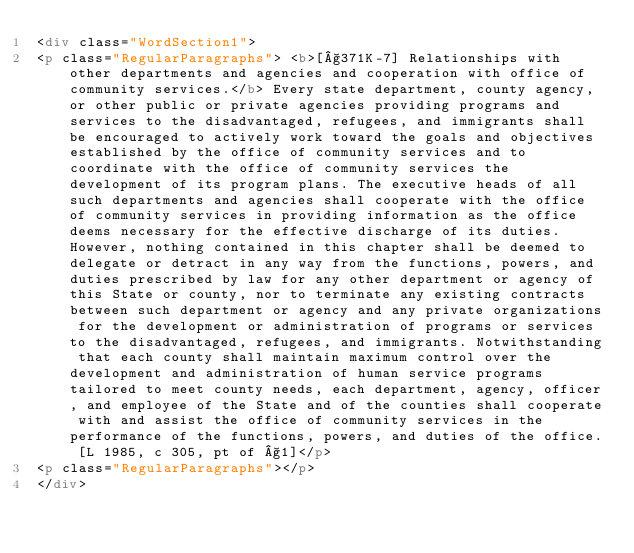<code> <loc_0><loc_0><loc_500><loc_500><_HTML_><div class="WordSection1">
<p class="RegularParagraphs"> <b>[§371K-7] Relationships with other departments and agencies and cooperation with office of community services.</b> Every state department, county agency, or other public or private agencies providing programs and services to the disadvantaged, refugees, and immigrants shall be encouraged to actively work toward the goals and objectives established by the office of community services and to coordinate with the office of community services the development of its program plans. The executive heads of all such departments and agencies shall cooperate with the office of community services in providing information as the office deems necessary for the effective discharge of its duties. However, nothing contained in this chapter shall be deemed to delegate or detract in any way from the functions, powers, and duties prescribed by law for any other department or agency of this State or county, nor to terminate any existing contracts between such department or agency and any private organizations for the development or administration of programs or services to the disadvantaged, refugees, and immigrants. Notwithstanding that each county shall maintain maximum control over the development and administration of human service programs tailored to meet county needs, each department, agency, officer, and employee of the State and of the counties shall cooperate with and assist the office of community services in the performance of the functions, powers, and duties of the office. [L 1985, c 305, pt of §1]</p>
<p class="RegularParagraphs"></p>
</div></code> 